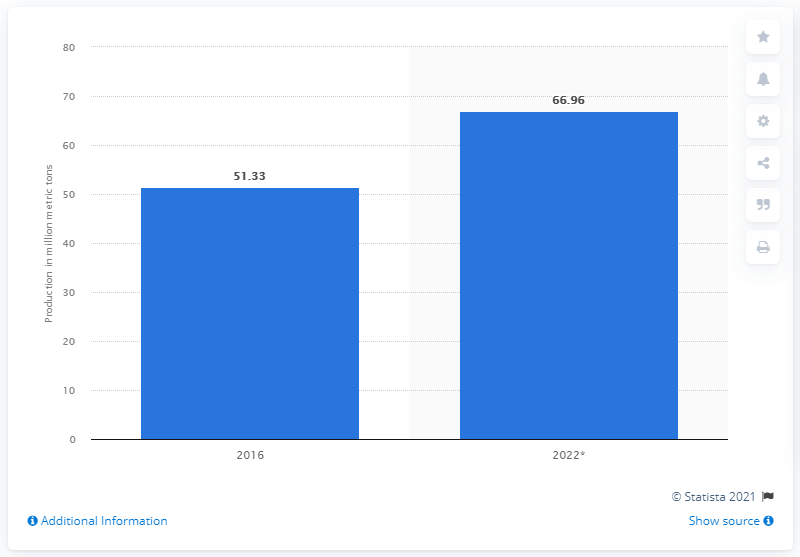Mention a couple of crucial points in this snapshot. According to projections, the global production volume of high-density polyethylene (HDPE) resin is expected to reach 66.96 million metric tons by 2022. HDPE resin was first produced globally in 2016. 